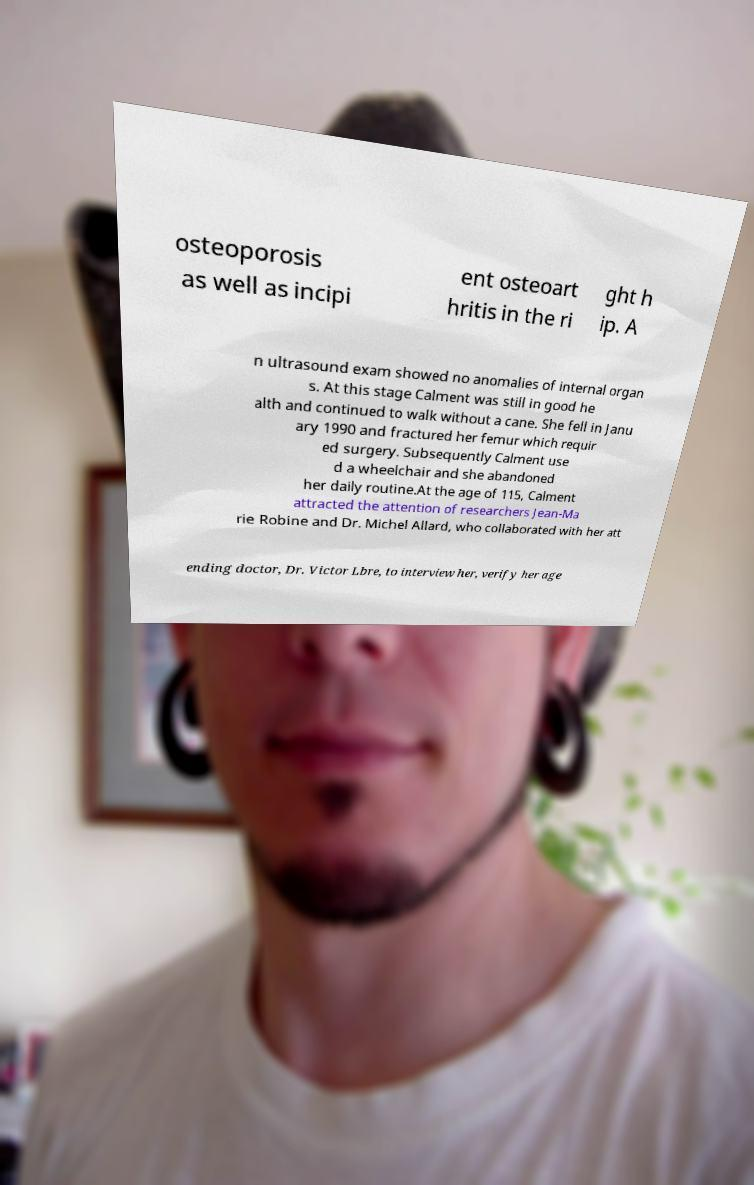Can you read and provide the text displayed in the image?This photo seems to have some interesting text. Can you extract and type it out for me? osteoporosis as well as incipi ent osteoart hritis in the ri ght h ip. A n ultrasound exam showed no anomalies of internal organ s. At this stage Calment was still in good he alth and continued to walk without a cane. She fell in Janu ary 1990 and fractured her femur which requir ed surgery. Subsequently Calment use d a wheelchair and she abandoned her daily routine.At the age of 115, Calment attracted the attention of researchers Jean-Ma rie Robine and Dr. Michel Allard, who collaborated with her att ending doctor, Dr. Victor Lbre, to interview her, verify her age 